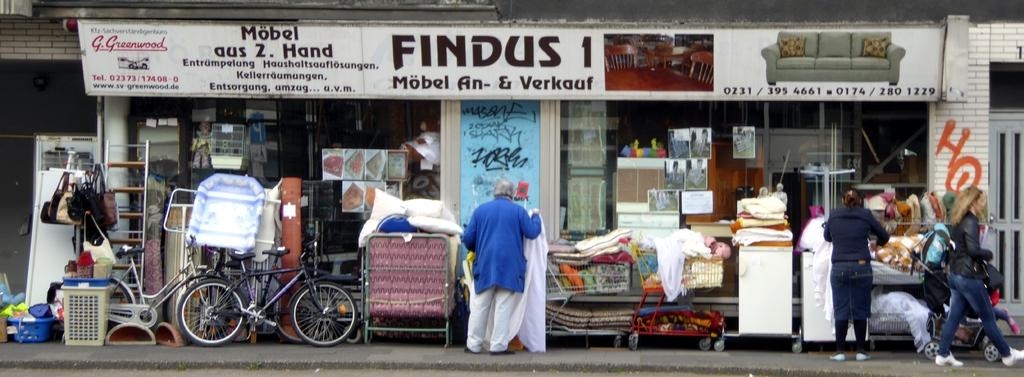<image>
Create a compact narrative representing the image presented. Several people window shopping on a street in front of a FINDUS 1 store. 